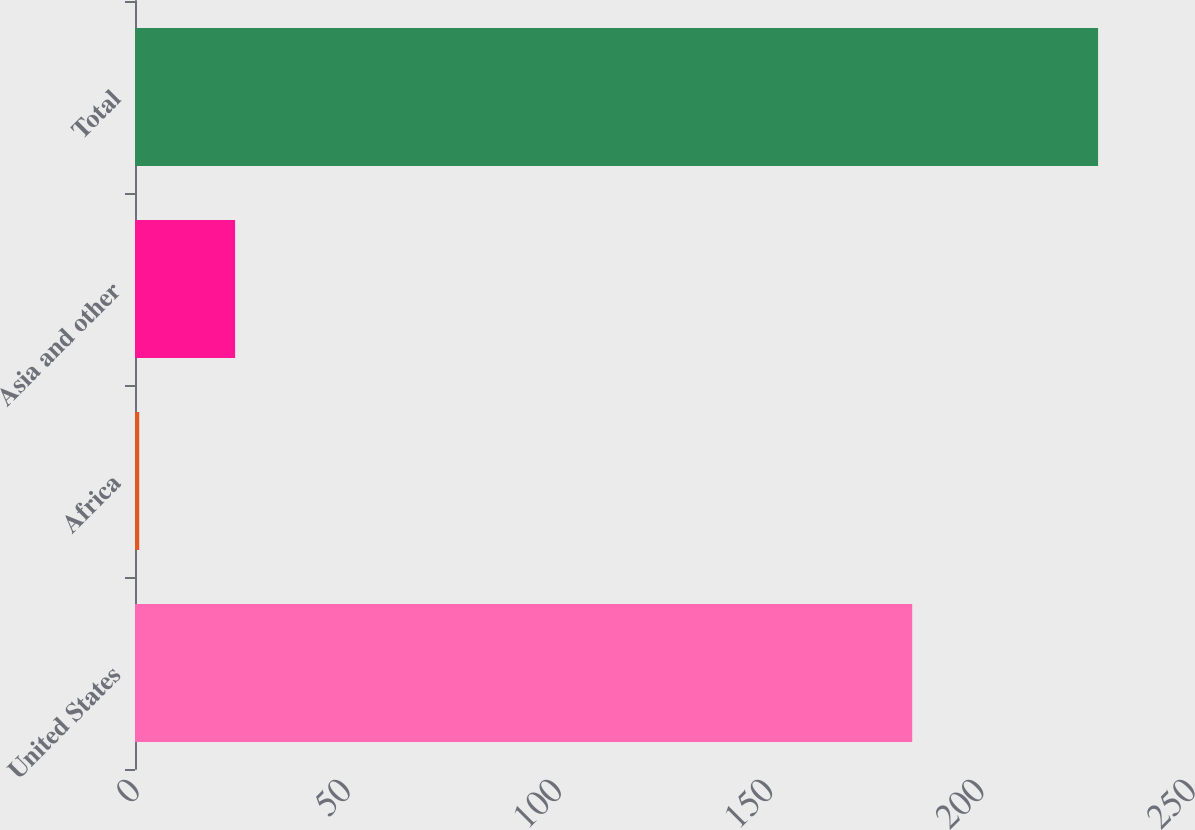<chart> <loc_0><loc_0><loc_500><loc_500><bar_chart><fcel>United States<fcel>Africa<fcel>Asia and other<fcel>Total<nl><fcel>184<fcel>1<fcel>23.7<fcel>228<nl></chart> 